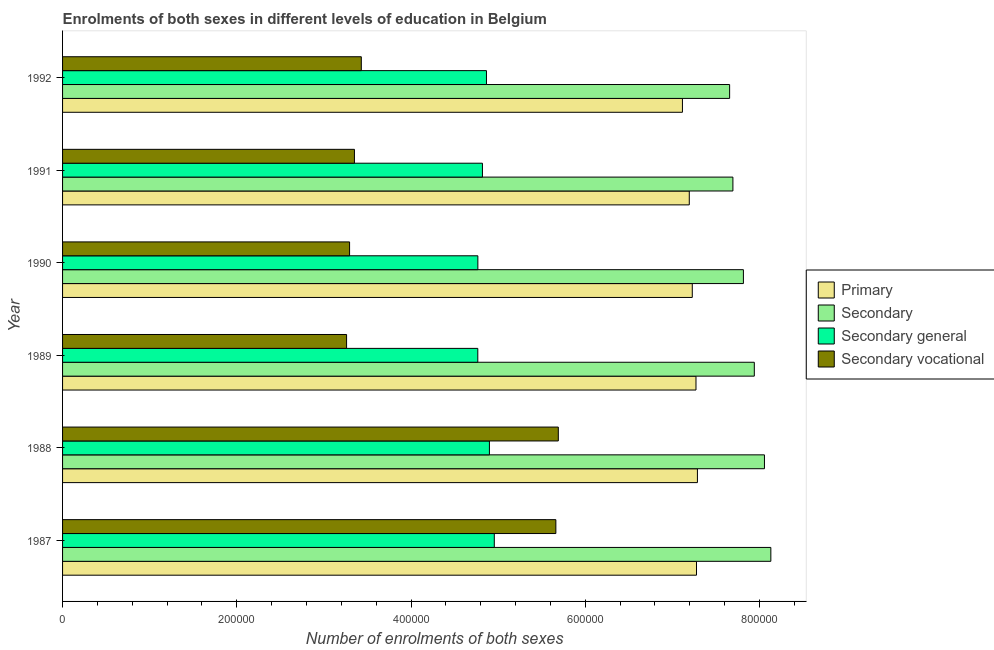How many different coloured bars are there?
Keep it short and to the point. 4. Are the number of bars per tick equal to the number of legend labels?
Make the answer very short. Yes. Are the number of bars on each tick of the Y-axis equal?
Give a very brief answer. Yes. How many bars are there on the 6th tick from the bottom?
Provide a succinct answer. 4. In how many cases, is the number of bars for a given year not equal to the number of legend labels?
Provide a short and direct response. 0. What is the number of enrolments in secondary general education in 1988?
Provide a short and direct response. 4.90e+05. Across all years, what is the maximum number of enrolments in secondary general education?
Offer a very short reply. 4.96e+05. Across all years, what is the minimum number of enrolments in secondary general education?
Provide a succinct answer. 4.77e+05. In which year was the number of enrolments in secondary general education minimum?
Provide a succinct answer. 1989. What is the total number of enrolments in secondary general education in the graph?
Provide a succinct answer. 2.91e+06. What is the difference between the number of enrolments in secondary vocational education in 1990 and that in 1991?
Keep it short and to the point. -5572. What is the difference between the number of enrolments in secondary education in 1988 and the number of enrolments in secondary general education in 1992?
Your answer should be compact. 3.19e+05. What is the average number of enrolments in secondary vocational education per year?
Your answer should be very brief. 4.11e+05. In the year 1991, what is the difference between the number of enrolments in secondary vocational education and number of enrolments in secondary general education?
Your answer should be compact. -1.47e+05. In how many years, is the number of enrolments in secondary vocational education greater than 680000 ?
Your answer should be compact. 0. What is the difference between the highest and the second highest number of enrolments in primary education?
Offer a terse response. 1071. What is the difference between the highest and the lowest number of enrolments in secondary education?
Keep it short and to the point. 4.73e+04. Is the sum of the number of enrolments in secondary vocational education in 1990 and 1992 greater than the maximum number of enrolments in secondary general education across all years?
Your answer should be compact. Yes. Is it the case that in every year, the sum of the number of enrolments in secondary education and number of enrolments in primary education is greater than the sum of number of enrolments in secondary vocational education and number of enrolments in secondary general education?
Your answer should be very brief. No. What does the 2nd bar from the top in 1987 represents?
Your answer should be compact. Secondary general. What does the 4th bar from the bottom in 1989 represents?
Provide a succinct answer. Secondary vocational. Is it the case that in every year, the sum of the number of enrolments in primary education and number of enrolments in secondary education is greater than the number of enrolments in secondary general education?
Offer a terse response. Yes. How many bars are there?
Keep it short and to the point. 24. How many years are there in the graph?
Ensure brevity in your answer.  6. What is the difference between two consecutive major ticks on the X-axis?
Offer a very short reply. 2.00e+05. Does the graph contain any zero values?
Your answer should be very brief. No. Does the graph contain grids?
Make the answer very short. No. Where does the legend appear in the graph?
Your answer should be compact. Center right. How are the legend labels stacked?
Ensure brevity in your answer.  Vertical. What is the title of the graph?
Your response must be concise. Enrolments of both sexes in different levels of education in Belgium. What is the label or title of the X-axis?
Provide a short and direct response. Number of enrolments of both sexes. What is the Number of enrolments of both sexes of Primary in 1987?
Keep it short and to the point. 7.28e+05. What is the Number of enrolments of both sexes in Secondary in 1987?
Provide a short and direct response. 8.13e+05. What is the Number of enrolments of both sexes in Secondary general in 1987?
Make the answer very short. 4.96e+05. What is the Number of enrolments of both sexes in Secondary vocational in 1987?
Offer a terse response. 5.66e+05. What is the Number of enrolments of both sexes in Primary in 1988?
Provide a short and direct response. 7.29e+05. What is the Number of enrolments of both sexes in Secondary in 1988?
Your answer should be compact. 8.06e+05. What is the Number of enrolments of both sexes in Secondary general in 1988?
Keep it short and to the point. 4.90e+05. What is the Number of enrolments of both sexes of Secondary vocational in 1988?
Provide a short and direct response. 5.69e+05. What is the Number of enrolments of both sexes of Primary in 1989?
Your answer should be very brief. 7.27e+05. What is the Number of enrolments of both sexes in Secondary in 1989?
Your answer should be very brief. 7.94e+05. What is the Number of enrolments of both sexes in Secondary general in 1989?
Your answer should be compact. 4.77e+05. What is the Number of enrolments of both sexes in Secondary vocational in 1989?
Provide a short and direct response. 3.26e+05. What is the Number of enrolments of both sexes in Primary in 1990?
Your response must be concise. 7.23e+05. What is the Number of enrolments of both sexes in Secondary in 1990?
Provide a succinct answer. 7.81e+05. What is the Number of enrolments of both sexes of Secondary general in 1990?
Your answer should be compact. 4.77e+05. What is the Number of enrolments of both sexes in Secondary vocational in 1990?
Provide a short and direct response. 3.29e+05. What is the Number of enrolments of both sexes of Primary in 1991?
Provide a succinct answer. 7.19e+05. What is the Number of enrolments of both sexes of Secondary in 1991?
Your response must be concise. 7.69e+05. What is the Number of enrolments of both sexes of Secondary general in 1991?
Keep it short and to the point. 4.82e+05. What is the Number of enrolments of both sexes of Secondary vocational in 1991?
Provide a succinct answer. 3.35e+05. What is the Number of enrolments of both sexes of Primary in 1992?
Your answer should be compact. 7.12e+05. What is the Number of enrolments of both sexes in Secondary in 1992?
Your answer should be very brief. 7.66e+05. What is the Number of enrolments of both sexes in Secondary general in 1992?
Give a very brief answer. 4.87e+05. What is the Number of enrolments of both sexes in Secondary vocational in 1992?
Offer a very short reply. 3.43e+05. Across all years, what is the maximum Number of enrolments of both sexes in Primary?
Provide a short and direct response. 7.29e+05. Across all years, what is the maximum Number of enrolments of both sexes in Secondary?
Your answer should be compact. 8.13e+05. Across all years, what is the maximum Number of enrolments of both sexes of Secondary general?
Ensure brevity in your answer.  4.96e+05. Across all years, what is the maximum Number of enrolments of both sexes of Secondary vocational?
Offer a terse response. 5.69e+05. Across all years, what is the minimum Number of enrolments of both sexes of Primary?
Your answer should be very brief. 7.12e+05. Across all years, what is the minimum Number of enrolments of both sexes of Secondary?
Your answer should be very brief. 7.66e+05. Across all years, what is the minimum Number of enrolments of both sexes of Secondary general?
Make the answer very short. 4.77e+05. Across all years, what is the minimum Number of enrolments of both sexes in Secondary vocational?
Your answer should be very brief. 3.26e+05. What is the total Number of enrolments of both sexes of Primary in the graph?
Your answer should be compact. 4.34e+06. What is the total Number of enrolments of both sexes of Secondary in the graph?
Ensure brevity in your answer.  4.73e+06. What is the total Number of enrolments of both sexes in Secondary general in the graph?
Ensure brevity in your answer.  2.91e+06. What is the total Number of enrolments of both sexes in Secondary vocational in the graph?
Provide a short and direct response. 2.47e+06. What is the difference between the Number of enrolments of both sexes in Primary in 1987 and that in 1988?
Your answer should be compact. -1071. What is the difference between the Number of enrolments of both sexes in Secondary in 1987 and that in 1988?
Your answer should be compact. 7344. What is the difference between the Number of enrolments of both sexes in Secondary general in 1987 and that in 1988?
Give a very brief answer. 5603. What is the difference between the Number of enrolments of both sexes in Secondary vocational in 1987 and that in 1988?
Your answer should be compact. -2811. What is the difference between the Number of enrolments of both sexes in Primary in 1987 and that in 1989?
Ensure brevity in your answer.  587. What is the difference between the Number of enrolments of both sexes in Secondary in 1987 and that in 1989?
Your response must be concise. 1.90e+04. What is the difference between the Number of enrolments of both sexes of Secondary general in 1987 and that in 1989?
Offer a terse response. 1.89e+04. What is the difference between the Number of enrolments of both sexes of Secondary vocational in 1987 and that in 1989?
Give a very brief answer. 2.40e+05. What is the difference between the Number of enrolments of both sexes in Primary in 1987 and that in 1990?
Keep it short and to the point. 4836. What is the difference between the Number of enrolments of both sexes of Secondary in 1987 and that in 1990?
Provide a succinct answer. 3.15e+04. What is the difference between the Number of enrolments of both sexes of Secondary general in 1987 and that in 1990?
Your answer should be very brief. 1.89e+04. What is the difference between the Number of enrolments of both sexes in Secondary vocational in 1987 and that in 1990?
Provide a succinct answer. 2.37e+05. What is the difference between the Number of enrolments of both sexes in Primary in 1987 and that in 1991?
Make the answer very short. 8275. What is the difference between the Number of enrolments of both sexes of Secondary in 1987 and that in 1991?
Offer a terse response. 4.36e+04. What is the difference between the Number of enrolments of both sexes in Secondary general in 1987 and that in 1991?
Offer a very short reply. 1.36e+04. What is the difference between the Number of enrolments of both sexes of Secondary vocational in 1987 and that in 1991?
Your answer should be compact. 2.31e+05. What is the difference between the Number of enrolments of both sexes in Primary in 1987 and that in 1992?
Your answer should be compact. 1.61e+04. What is the difference between the Number of enrolments of both sexes of Secondary in 1987 and that in 1992?
Provide a succinct answer. 4.73e+04. What is the difference between the Number of enrolments of both sexes of Secondary general in 1987 and that in 1992?
Make the answer very short. 8979. What is the difference between the Number of enrolments of both sexes in Secondary vocational in 1987 and that in 1992?
Provide a short and direct response. 2.23e+05. What is the difference between the Number of enrolments of both sexes in Primary in 1988 and that in 1989?
Your answer should be compact. 1658. What is the difference between the Number of enrolments of both sexes in Secondary in 1988 and that in 1989?
Give a very brief answer. 1.16e+04. What is the difference between the Number of enrolments of both sexes in Secondary general in 1988 and that in 1989?
Provide a succinct answer. 1.33e+04. What is the difference between the Number of enrolments of both sexes of Secondary vocational in 1988 and that in 1989?
Offer a very short reply. 2.43e+05. What is the difference between the Number of enrolments of both sexes of Primary in 1988 and that in 1990?
Give a very brief answer. 5907. What is the difference between the Number of enrolments of both sexes in Secondary in 1988 and that in 1990?
Offer a terse response. 2.42e+04. What is the difference between the Number of enrolments of both sexes of Secondary general in 1988 and that in 1990?
Give a very brief answer. 1.33e+04. What is the difference between the Number of enrolments of both sexes in Secondary vocational in 1988 and that in 1990?
Your answer should be very brief. 2.40e+05. What is the difference between the Number of enrolments of both sexes in Primary in 1988 and that in 1991?
Keep it short and to the point. 9346. What is the difference between the Number of enrolments of both sexes in Secondary in 1988 and that in 1991?
Provide a succinct answer. 3.62e+04. What is the difference between the Number of enrolments of both sexes in Secondary general in 1988 and that in 1991?
Offer a very short reply. 8005. What is the difference between the Number of enrolments of both sexes of Secondary vocational in 1988 and that in 1991?
Provide a succinct answer. 2.34e+05. What is the difference between the Number of enrolments of both sexes of Primary in 1988 and that in 1992?
Make the answer very short. 1.72e+04. What is the difference between the Number of enrolments of both sexes of Secondary in 1988 and that in 1992?
Your answer should be very brief. 4.00e+04. What is the difference between the Number of enrolments of both sexes in Secondary general in 1988 and that in 1992?
Your answer should be very brief. 3376. What is the difference between the Number of enrolments of both sexes in Secondary vocational in 1988 and that in 1992?
Provide a succinct answer. 2.26e+05. What is the difference between the Number of enrolments of both sexes of Primary in 1989 and that in 1990?
Your answer should be very brief. 4249. What is the difference between the Number of enrolments of both sexes of Secondary in 1989 and that in 1990?
Keep it short and to the point. 1.25e+04. What is the difference between the Number of enrolments of both sexes in Secondary general in 1989 and that in 1990?
Offer a terse response. -78. What is the difference between the Number of enrolments of both sexes in Secondary vocational in 1989 and that in 1990?
Offer a terse response. -3443. What is the difference between the Number of enrolments of both sexes of Primary in 1989 and that in 1991?
Offer a very short reply. 7688. What is the difference between the Number of enrolments of both sexes of Secondary in 1989 and that in 1991?
Your answer should be compact. 2.46e+04. What is the difference between the Number of enrolments of both sexes of Secondary general in 1989 and that in 1991?
Provide a short and direct response. -5336. What is the difference between the Number of enrolments of both sexes of Secondary vocational in 1989 and that in 1991?
Provide a short and direct response. -9015. What is the difference between the Number of enrolments of both sexes in Primary in 1989 and that in 1992?
Provide a short and direct response. 1.55e+04. What is the difference between the Number of enrolments of both sexes in Secondary in 1989 and that in 1992?
Offer a very short reply. 2.84e+04. What is the difference between the Number of enrolments of both sexes in Secondary general in 1989 and that in 1992?
Give a very brief answer. -9965. What is the difference between the Number of enrolments of both sexes of Secondary vocational in 1989 and that in 1992?
Your answer should be very brief. -1.69e+04. What is the difference between the Number of enrolments of both sexes of Primary in 1990 and that in 1991?
Provide a short and direct response. 3439. What is the difference between the Number of enrolments of both sexes in Secondary in 1990 and that in 1991?
Keep it short and to the point. 1.20e+04. What is the difference between the Number of enrolments of both sexes of Secondary general in 1990 and that in 1991?
Offer a terse response. -5258. What is the difference between the Number of enrolments of both sexes of Secondary vocational in 1990 and that in 1991?
Offer a terse response. -5572. What is the difference between the Number of enrolments of both sexes in Primary in 1990 and that in 1992?
Offer a terse response. 1.13e+04. What is the difference between the Number of enrolments of both sexes of Secondary in 1990 and that in 1992?
Keep it short and to the point. 1.58e+04. What is the difference between the Number of enrolments of both sexes of Secondary general in 1990 and that in 1992?
Your answer should be compact. -9887. What is the difference between the Number of enrolments of both sexes of Secondary vocational in 1990 and that in 1992?
Give a very brief answer. -1.35e+04. What is the difference between the Number of enrolments of both sexes of Primary in 1991 and that in 1992?
Keep it short and to the point. 7851. What is the difference between the Number of enrolments of both sexes of Secondary in 1991 and that in 1992?
Provide a succinct answer. 3766. What is the difference between the Number of enrolments of both sexes of Secondary general in 1991 and that in 1992?
Make the answer very short. -4629. What is the difference between the Number of enrolments of both sexes of Secondary vocational in 1991 and that in 1992?
Give a very brief answer. -7892. What is the difference between the Number of enrolments of both sexes of Primary in 1987 and the Number of enrolments of both sexes of Secondary in 1988?
Your response must be concise. -7.80e+04. What is the difference between the Number of enrolments of both sexes in Primary in 1987 and the Number of enrolments of both sexes in Secondary general in 1988?
Ensure brevity in your answer.  2.38e+05. What is the difference between the Number of enrolments of both sexes of Primary in 1987 and the Number of enrolments of both sexes of Secondary vocational in 1988?
Provide a short and direct response. 1.59e+05. What is the difference between the Number of enrolments of both sexes in Secondary in 1987 and the Number of enrolments of both sexes in Secondary general in 1988?
Keep it short and to the point. 3.23e+05. What is the difference between the Number of enrolments of both sexes of Secondary in 1987 and the Number of enrolments of both sexes of Secondary vocational in 1988?
Provide a succinct answer. 2.44e+05. What is the difference between the Number of enrolments of both sexes in Secondary general in 1987 and the Number of enrolments of both sexes in Secondary vocational in 1988?
Give a very brief answer. -7.35e+04. What is the difference between the Number of enrolments of both sexes of Primary in 1987 and the Number of enrolments of both sexes of Secondary in 1989?
Give a very brief answer. -6.64e+04. What is the difference between the Number of enrolments of both sexes of Primary in 1987 and the Number of enrolments of both sexes of Secondary general in 1989?
Offer a terse response. 2.51e+05. What is the difference between the Number of enrolments of both sexes of Primary in 1987 and the Number of enrolments of both sexes of Secondary vocational in 1989?
Offer a terse response. 4.02e+05. What is the difference between the Number of enrolments of both sexes in Secondary in 1987 and the Number of enrolments of both sexes in Secondary general in 1989?
Provide a succinct answer. 3.36e+05. What is the difference between the Number of enrolments of both sexes of Secondary in 1987 and the Number of enrolments of both sexes of Secondary vocational in 1989?
Make the answer very short. 4.87e+05. What is the difference between the Number of enrolments of both sexes in Secondary general in 1987 and the Number of enrolments of both sexes in Secondary vocational in 1989?
Your answer should be compact. 1.70e+05. What is the difference between the Number of enrolments of both sexes in Primary in 1987 and the Number of enrolments of both sexes in Secondary in 1990?
Offer a terse response. -5.38e+04. What is the difference between the Number of enrolments of both sexes in Primary in 1987 and the Number of enrolments of both sexes in Secondary general in 1990?
Offer a very short reply. 2.51e+05. What is the difference between the Number of enrolments of both sexes in Primary in 1987 and the Number of enrolments of both sexes in Secondary vocational in 1990?
Your answer should be very brief. 3.98e+05. What is the difference between the Number of enrolments of both sexes of Secondary in 1987 and the Number of enrolments of both sexes of Secondary general in 1990?
Your answer should be compact. 3.36e+05. What is the difference between the Number of enrolments of both sexes in Secondary in 1987 and the Number of enrolments of both sexes in Secondary vocational in 1990?
Your response must be concise. 4.84e+05. What is the difference between the Number of enrolments of both sexes in Secondary general in 1987 and the Number of enrolments of both sexes in Secondary vocational in 1990?
Your answer should be compact. 1.66e+05. What is the difference between the Number of enrolments of both sexes of Primary in 1987 and the Number of enrolments of both sexes of Secondary in 1991?
Keep it short and to the point. -4.18e+04. What is the difference between the Number of enrolments of both sexes in Primary in 1987 and the Number of enrolments of both sexes in Secondary general in 1991?
Your answer should be very brief. 2.46e+05. What is the difference between the Number of enrolments of both sexes of Primary in 1987 and the Number of enrolments of both sexes of Secondary vocational in 1991?
Keep it short and to the point. 3.93e+05. What is the difference between the Number of enrolments of both sexes of Secondary in 1987 and the Number of enrolments of both sexes of Secondary general in 1991?
Make the answer very short. 3.31e+05. What is the difference between the Number of enrolments of both sexes of Secondary in 1987 and the Number of enrolments of both sexes of Secondary vocational in 1991?
Offer a very short reply. 4.78e+05. What is the difference between the Number of enrolments of both sexes of Secondary general in 1987 and the Number of enrolments of both sexes of Secondary vocational in 1991?
Make the answer very short. 1.61e+05. What is the difference between the Number of enrolments of both sexes of Primary in 1987 and the Number of enrolments of both sexes of Secondary in 1992?
Your answer should be compact. -3.80e+04. What is the difference between the Number of enrolments of both sexes of Primary in 1987 and the Number of enrolments of both sexes of Secondary general in 1992?
Your answer should be compact. 2.41e+05. What is the difference between the Number of enrolments of both sexes in Primary in 1987 and the Number of enrolments of both sexes in Secondary vocational in 1992?
Offer a terse response. 3.85e+05. What is the difference between the Number of enrolments of both sexes of Secondary in 1987 and the Number of enrolments of both sexes of Secondary general in 1992?
Provide a short and direct response. 3.26e+05. What is the difference between the Number of enrolments of both sexes of Secondary in 1987 and the Number of enrolments of both sexes of Secondary vocational in 1992?
Make the answer very short. 4.70e+05. What is the difference between the Number of enrolments of both sexes of Secondary general in 1987 and the Number of enrolments of both sexes of Secondary vocational in 1992?
Make the answer very short. 1.53e+05. What is the difference between the Number of enrolments of both sexes in Primary in 1988 and the Number of enrolments of both sexes in Secondary in 1989?
Provide a succinct answer. -6.53e+04. What is the difference between the Number of enrolments of both sexes of Primary in 1988 and the Number of enrolments of both sexes of Secondary general in 1989?
Your answer should be very brief. 2.52e+05. What is the difference between the Number of enrolments of both sexes in Primary in 1988 and the Number of enrolments of both sexes in Secondary vocational in 1989?
Your answer should be very brief. 4.03e+05. What is the difference between the Number of enrolments of both sexes in Secondary in 1988 and the Number of enrolments of both sexes in Secondary general in 1989?
Offer a terse response. 3.29e+05. What is the difference between the Number of enrolments of both sexes in Secondary in 1988 and the Number of enrolments of both sexes in Secondary vocational in 1989?
Offer a very short reply. 4.80e+05. What is the difference between the Number of enrolments of both sexes in Secondary general in 1988 and the Number of enrolments of both sexes in Secondary vocational in 1989?
Keep it short and to the point. 1.64e+05. What is the difference between the Number of enrolments of both sexes in Primary in 1988 and the Number of enrolments of both sexes in Secondary in 1990?
Provide a succinct answer. -5.28e+04. What is the difference between the Number of enrolments of both sexes of Primary in 1988 and the Number of enrolments of both sexes of Secondary general in 1990?
Make the answer very short. 2.52e+05. What is the difference between the Number of enrolments of both sexes of Primary in 1988 and the Number of enrolments of both sexes of Secondary vocational in 1990?
Provide a succinct answer. 3.99e+05. What is the difference between the Number of enrolments of both sexes in Secondary in 1988 and the Number of enrolments of both sexes in Secondary general in 1990?
Give a very brief answer. 3.29e+05. What is the difference between the Number of enrolments of both sexes in Secondary in 1988 and the Number of enrolments of both sexes in Secondary vocational in 1990?
Your answer should be very brief. 4.76e+05. What is the difference between the Number of enrolments of both sexes of Secondary general in 1988 and the Number of enrolments of both sexes of Secondary vocational in 1990?
Give a very brief answer. 1.61e+05. What is the difference between the Number of enrolments of both sexes of Primary in 1988 and the Number of enrolments of both sexes of Secondary in 1991?
Keep it short and to the point. -4.07e+04. What is the difference between the Number of enrolments of both sexes of Primary in 1988 and the Number of enrolments of both sexes of Secondary general in 1991?
Your answer should be compact. 2.47e+05. What is the difference between the Number of enrolments of both sexes in Primary in 1988 and the Number of enrolments of both sexes in Secondary vocational in 1991?
Keep it short and to the point. 3.94e+05. What is the difference between the Number of enrolments of both sexes in Secondary in 1988 and the Number of enrolments of both sexes in Secondary general in 1991?
Keep it short and to the point. 3.24e+05. What is the difference between the Number of enrolments of both sexes in Secondary in 1988 and the Number of enrolments of both sexes in Secondary vocational in 1991?
Make the answer very short. 4.71e+05. What is the difference between the Number of enrolments of both sexes in Secondary general in 1988 and the Number of enrolments of both sexes in Secondary vocational in 1991?
Keep it short and to the point. 1.55e+05. What is the difference between the Number of enrolments of both sexes of Primary in 1988 and the Number of enrolments of both sexes of Secondary in 1992?
Provide a short and direct response. -3.70e+04. What is the difference between the Number of enrolments of both sexes of Primary in 1988 and the Number of enrolments of both sexes of Secondary general in 1992?
Give a very brief answer. 2.42e+05. What is the difference between the Number of enrolments of both sexes of Primary in 1988 and the Number of enrolments of both sexes of Secondary vocational in 1992?
Keep it short and to the point. 3.86e+05. What is the difference between the Number of enrolments of both sexes in Secondary in 1988 and the Number of enrolments of both sexes in Secondary general in 1992?
Ensure brevity in your answer.  3.19e+05. What is the difference between the Number of enrolments of both sexes in Secondary in 1988 and the Number of enrolments of both sexes in Secondary vocational in 1992?
Keep it short and to the point. 4.63e+05. What is the difference between the Number of enrolments of both sexes of Secondary general in 1988 and the Number of enrolments of both sexes of Secondary vocational in 1992?
Your response must be concise. 1.47e+05. What is the difference between the Number of enrolments of both sexes in Primary in 1989 and the Number of enrolments of both sexes in Secondary in 1990?
Offer a terse response. -5.44e+04. What is the difference between the Number of enrolments of both sexes in Primary in 1989 and the Number of enrolments of both sexes in Secondary general in 1990?
Make the answer very short. 2.50e+05. What is the difference between the Number of enrolments of both sexes of Primary in 1989 and the Number of enrolments of both sexes of Secondary vocational in 1990?
Give a very brief answer. 3.98e+05. What is the difference between the Number of enrolments of both sexes of Secondary in 1989 and the Number of enrolments of both sexes of Secondary general in 1990?
Give a very brief answer. 3.17e+05. What is the difference between the Number of enrolments of both sexes in Secondary in 1989 and the Number of enrolments of both sexes in Secondary vocational in 1990?
Your answer should be very brief. 4.65e+05. What is the difference between the Number of enrolments of both sexes in Secondary general in 1989 and the Number of enrolments of both sexes in Secondary vocational in 1990?
Give a very brief answer. 1.47e+05. What is the difference between the Number of enrolments of both sexes of Primary in 1989 and the Number of enrolments of both sexes of Secondary in 1991?
Provide a succinct answer. -4.24e+04. What is the difference between the Number of enrolments of both sexes of Primary in 1989 and the Number of enrolments of both sexes of Secondary general in 1991?
Keep it short and to the point. 2.45e+05. What is the difference between the Number of enrolments of both sexes in Primary in 1989 and the Number of enrolments of both sexes in Secondary vocational in 1991?
Make the answer very short. 3.92e+05. What is the difference between the Number of enrolments of both sexes of Secondary in 1989 and the Number of enrolments of both sexes of Secondary general in 1991?
Your response must be concise. 3.12e+05. What is the difference between the Number of enrolments of both sexes of Secondary in 1989 and the Number of enrolments of both sexes of Secondary vocational in 1991?
Offer a very short reply. 4.59e+05. What is the difference between the Number of enrolments of both sexes of Secondary general in 1989 and the Number of enrolments of both sexes of Secondary vocational in 1991?
Make the answer very short. 1.42e+05. What is the difference between the Number of enrolments of both sexes in Primary in 1989 and the Number of enrolments of both sexes in Secondary in 1992?
Your answer should be very brief. -3.86e+04. What is the difference between the Number of enrolments of both sexes in Primary in 1989 and the Number of enrolments of both sexes in Secondary general in 1992?
Provide a succinct answer. 2.40e+05. What is the difference between the Number of enrolments of both sexes of Primary in 1989 and the Number of enrolments of both sexes of Secondary vocational in 1992?
Give a very brief answer. 3.84e+05. What is the difference between the Number of enrolments of both sexes in Secondary in 1989 and the Number of enrolments of both sexes in Secondary general in 1992?
Give a very brief answer. 3.07e+05. What is the difference between the Number of enrolments of both sexes in Secondary in 1989 and the Number of enrolments of both sexes in Secondary vocational in 1992?
Your answer should be very brief. 4.51e+05. What is the difference between the Number of enrolments of both sexes of Secondary general in 1989 and the Number of enrolments of both sexes of Secondary vocational in 1992?
Offer a terse response. 1.34e+05. What is the difference between the Number of enrolments of both sexes of Primary in 1990 and the Number of enrolments of both sexes of Secondary in 1991?
Offer a terse response. -4.66e+04. What is the difference between the Number of enrolments of both sexes of Primary in 1990 and the Number of enrolments of both sexes of Secondary general in 1991?
Keep it short and to the point. 2.41e+05. What is the difference between the Number of enrolments of both sexes of Primary in 1990 and the Number of enrolments of both sexes of Secondary vocational in 1991?
Your response must be concise. 3.88e+05. What is the difference between the Number of enrolments of both sexes in Secondary in 1990 and the Number of enrolments of both sexes in Secondary general in 1991?
Provide a short and direct response. 3.00e+05. What is the difference between the Number of enrolments of both sexes in Secondary in 1990 and the Number of enrolments of both sexes in Secondary vocational in 1991?
Your answer should be very brief. 4.46e+05. What is the difference between the Number of enrolments of both sexes of Secondary general in 1990 and the Number of enrolments of both sexes of Secondary vocational in 1991?
Keep it short and to the point. 1.42e+05. What is the difference between the Number of enrolments of both sexes in Primary in 1990 and the Number of enrolments of both sexes in Secondary in 1992?
Keep it short and to the point. -4.29e+04. What is the difference between the Number of enrolments of both sexes of Primary in 1990 and the Number of enrolments of both sexes of Secondary general in 1992?
Your answer should be very brief. 2.36e+05. What is the difference between the Number of enrolments of both sexes in Primary in 1990 and the Number of enrolments of both sexes in Secondary vocational in 1992?
Offer a terse response. 3.80e+05. What is the difference between the Number of enrolments of both sexes in Secondary in 1990 and the Number of enrolments of both sexes in Secondary general in 1992?
Make the answer very short. 2.95e+05. What is the difference between the Number of enrolments of both sexes in Secondary in 1990 and the Number of enrolments of both sexes in Secondary vocational in 1992?
Give a very brief answer. 4.39e+05. What is the difference between the Number of enrolments of both sexes of Secondary general in 1990 and the Number of enrolments of both sexes of Secondary vocational in 1992?
Offer a terse response. 1.34e+05. What is the difference between the Number of enrolments of both sexes in Primary in 1991 and the Number of enrolments of both sexes in Secondary in 1992?
Your response must be concise. -4.63e+04. What is the difference between the Number of enrolments of both sexes of Primary in 1991 and the Number of enrolments of both sexes of Secondary general in 1992?
Offer a very short reply. 2.33e+05. What is the difference between the Number of enrolments of both sexes of Primary in 1991 and the Number of enrolments of both sexes of Secondary vocational in 1992?
Provide a succinct answer. 3.76e+05. What is the difference between the Number of enrolments of both sexes in Secondary in 1991 and the Number of enrolments of both sexes in Secondary general in 1992?
Offer a very short reply. 2.83e+05. What is the difference between the Number of enrolments of both sexes in Secondary in 1991 and the Number of enrolments of both sexes in Secondary vocational in 1992?
Offer a terse response. 4.27e+05. What is the difference between the Number of enrolments of both sexes of Secondary general in 1991 and the Number of enrolments of both sexes of Secondary vocational in 1992?
Offer a terse response. 1.39e+05. What is the average Number of enrolments of both sexes of Primary per year?
Offer a terse response. 7.23e+05. What is the average Number of enrolments of both sexes in Secondary per year?
Ensure brevity in your answer.  7.88e+05. What is the average Number of enrolments of both sexes in Secondary general per year?
Ensure brevity in your answer.  4.85e+05. What is the average Number of enrolments of both sexes of Secondary vocational per year?
Your answer should be compact. 4.11e+05. In the year 1987, what is the difference between the Number of enrolments of both sexes in Primary and Number of enrolments of both sexes in Secondary?
Your answer should be very brief. -8.53e+04. In the year 1987, what is the difference between the Number of enrolments of both sexes of Primary and Number of enrolments of both sexes of Secondary general?
Your answer should be very brief. 2.32e+05. In the year 1987, what is the difference between the Number of enrolments of both sexes in Primary and Number of enrolments of both sexes in Secondary vocational?
Provide a short and direct response. 1.61e+05. In the year 1987, what is the difference between the Number of enrolments of both sexes in Secondary and Number of enrolments of both sexes in Secondary general?
Your answer should be very brief. 3.17e+05. In the year 1987, what is the difference between the Number of enrolments of both sexes in Secondary and Number of enrolments of both sexes in Secondary vocational?
Make the answer very short. 2.47e+05. In the year 1987, what is the difference between the Number of enrolments of both sexes in Secondary general and Number of enrolments of both sexes in Secondary vocational?
Provide a short and direct response. -7.07e+04. In the year 1988, what is the difference between the Number of enrolments of both sexes in Primary and Number of enrolments of both sexes in Secondary?
Ensure brevity in your answer.  -7.69e+04. In the year 1988, what is the difference between the Number of enrolments of both sexes of Primary and Number of enrolments of both sexes of Secondary general?
Offer a terse response. 2.39e+05. In the year 1988, what is the difference between the Number of enrolments of both sexes of Primary and Number of enrolments of both sexes of Secondary vocational?
Make the answer very short. 1.60e+05. In the year 1988, what is the difference between the Number of enrolments of both sexes of Secondary and Number of enrolments of both sexes of Secondary general?
Your response must be concise. 3.16e+05. In the year 1988, what is the difference between the Number of enrolments of both sexes in Secondary and Number of enrolments of both sexes in Secondary vocational?
Offer a terse response. 2.37e+05. In the year 1988, what is the difference between the Number of enrolments of both sexes in Secondary general and Number of enrolments of both sexes in Secondary vocational?
Offer a terse response. -7.91e+04. In the year 1989, what is the difference between the Number of enrolments of both sexes in Primary and Number of enrolments of both sexes in Secondary?
Keep it short and to the point. -6.70e+04. In the year 1989, what is the difference between the Number of enrolments of both sexes of Primary and Number of enrolments of both sexes of Secondary general?
Make the answer very short. 2.50e+05. In the year 1989, what is the difference between the Number of enrolments of both sexes of Primary and Number of enrolments of both sexes of Secondary vocational?
Provide a short and direct response. 4.01e+05. In the year 1989, what is the difference between the Number of enrolments of both sexes in Secondary and Number of enrolments of both sexes in Secondary general?
Offer a terse response. 3.17e+05. In the year 1989, what is the difference between the Number of enrolments of both sexes in Secondary and Number of enrolments of both sexes in Secondary vocational?
Make the answer very short. 4.68e+05. In the year 1989, what is the difference between the Number of enrolments of both sexes of Secondary general and Number of enrolments of both sexes of Secondary vocational?
Offer a very short reply. 1.51e+05. In the year 1990, what is the difference between the Number of enrolments of both sexes in Primary and Number of enrolments of both sexes in Secondary?
Ensure brevity in your answer.  -5.87e+04. In the year 1990, what is the difference between the Number of enrolments of both sexes in Primary and Number of enrolments of both sexes in Secondary general?
Make the answer very short. 2.46e+05. In the year 1990, what is the difference between the Number of enrolments of both sexes of Primary and Number of enrolments of both sexes of Secondary vocational?
Your answer should be compact. 3.93e+05. In the year 1990, what is the difference between the Number of enrolments of both sexes of Secondary and Number of enrolments of both sexes of Secondary general?
Keep it short and to the point. 3.05e+05. In the year 1990, what is the difference between the Number of enrolments of both sexes in Secondary and Number of enrolments of both sexes in Secondary vocational?
Your answer should be very brief. 4.52e+05. In the year 1990, what is the difference between the Number of enrolments of both sexes in Secondary general and Number of enrolments of both sexes in Secondary vocational?
Make the answer very short. 1.47e+05. In the year 1991, what is the difference between the Number of enrolments of both sexes of Primary and Number of enrolments of both sexes of Secondary?
Give a very brief answer. -5.01e+04. In the year 1991, what is the difference between the Number of enrolments of both sexes of Primary and Number of enrolments of both sexes of Secondary general?
Your response must be concise. 2.37e+05. In the year 1991, what is the difference between the Number of enrolments of both sexes of Primary and Number of enrolments of both sexes of Secondary vocational?
Offer a terse response. 3.84e+05. In the year 1991, what is the difference between the Number of enrolments of both sexes of Secondary and Number of enrolments of both sexes of Secondary general?
Provide a short and direct response. 2.87e+05. In the year 1991, what is the difference between the Number of enrolments of both sexes in Secondary and Number of enrolments of both sexes in Secondary vocational?
Your response must be concise. 4.34e+05. In the year 1991, what is the difference between the Number of enrolments of both sexes of Secondary general and Number of enrolments of both sexes of Secondary vocational?
Make the answer very short. 1.47e+05. In the year 1992, what is the difference between the Number of enrolments of both sexes of Primary and Number of enrolments of both sexes of Secondary?
Your answer should be compact. -5.42e+04. In the year 1992, what is the difference between the Number of enrolments of both sexes of Primary and Number of enrolments of both sexes of Secondary general?
Provide a short and direct response. 2.25e+05. In the year 1992, what is the difference between the Number of enrolments of both sexes in Primary and Number of enrolments of both sexes in Secondary vocational?
Make the answer very short. 3.69e+05. In the year 1992, what is the difference between the Number of enrolments of both sexes of Secondary and Number of enrolments of both sexes of Secondary general?
Offer a very short reply. 2.79e+05. In the year 1992, what is the difference between the Number of enrolments of both sexes in Secondary and Number of enrolments of both sexes in Secondary vocational?
Keep it short and to the point. 4.23e+05. In the year 1992, what is the difference between the Number of enrolments of both sexes of Secondary general and Number of enrolments of both sexes of Secondary vocational?
Your answer should be very brief. 1.44e+05. What is the ratio of the Number of enrolments of both sexes of Secondary in 1987 to that in 1988?
Offer a terse response. 1.01. What is the ratio of the Number of enrolments of both sexes of Secondary general in 1987 to that in 1988?
Provide a succinct answer. 1.01. What is the ratio of the Number of enrolments of both sexes in Secondary in 1987 to that in 1989?
Provide a succinct answer. 1.02. What is the ratio of the Number of enrolments of both sexes in Secondary general in 1987 to that in 1989?
Offer a terse response. 1.04. What is the ratio of the Number of enrolments of both sexes in Secondary vocational in 1987 to that in 1989?
Give a very brief answer. 1.74. What is the ratio of the Number of enrolments of both sexes of Secondary in 1987 to that in 1990?
Provide a succinct answer. 1.04. What is the ratio of the Number of enrolments of both sexes of Secondary general in 1987 to that in 1990?
Provide a succinct answer. 1.04. What is the ratio of the Number of enrolments of both sexes in Secondary vocational in 1987 to that in 1990?
Your response must be concise. 1.72. What is the ratio of the Number of enrolments of both sexes in Primary in 1987 to that in 1991?
Give a very brief answer. 1.01. What is the ratio of the Number of enrolments of both sexes in Secondary in 1987 to that in 1991?
Offer a terse response. 1.06. What is the ratio of the Number of enrolments of both sexes of Secondary general in 1987 to that in 1991?
Offer a terse response. 1.03. What is the ratio of the Number of enrolments of both sexes in Secondary vocational in 1987 to that in 1991?
Your response must be concise. 1.69. What is the ratio of the Number of enrolments of both sexes of Primary in 1987 to that in 1992?
Keep it short and to the point. 1.02. What is the ratio of the Number of enrolments of both sexes in Secondary in 1987 to that in 1992?
Give a very brief answer. 1.06. What is the ratio of the Number of enrolments of both sexes of Secondary general in 1987 to that in 1992?
Keep it short and to the point. 1.02. What is the ratio of the Number of enrolments of both sexes of Secondary vocational in 1987 to that in 1992?
Give a very brief answer. 1.65. What is the ratio of the Number of enrolments of both sexes of Primary in 1988 to that in 1989?
Give a very brief answer. 1. What is the ratio of the Number of enrolments of both sexes of Secondary in 1988 to that in 1989?
Provide a short and direct response. 1.01. What is the ratio of the Number of enrolments of both sexes of Secondary general in 1988 to that in 1989?
Offer a terse response. 1.03. What is the ratio of the Number of enrolments of both sexes of Secondary vocational in 1988 to that in 1989?
Provide a short and direct response. 1.75. What is the ratio of the Number of enrolments of both sexes in Primary in 1988 to that in 1990?
Make the answer very short. 1.01. What is the ratio of the Number of enrolments of both sexes of Secondary in 1988 to that in 1990?
Offer a terse response. 1.03. What is the ratio of the Number of enrolments of both sexes in Secondary general in 1988 to that in 1990?
Your response must be concise. 1.03. What is the ratio of the Number of enrolments of both sexes of Secondary vocational in 1988 to that in 1990?
Provide a succinct answer. 1.73. What is the ratio of the Number of enrolments of both sexes in Secondary in 1988 to that in 1991?
Provide a succinct answer. 1.05. What is the ratio of the Number of enrolments of both sexes in Secondary general in 1988 to that in 1991?
Offer a very short reply. 1.02. What is the ratio of the Number of enrolments of both sexes of Secondary vocational in 1988 to that in 1991?
Make the answer very short. 1.7. What is the ratio of the Number of enrolments of both sexes of Primary in 1988 to that in 1992?
Your answer should be compact. 1.02. What is the ratio of the Number of enrolments of both sexes of Secondary in 1988 to that in 1992?
Your answer should be very brief. 1.05. What is the ratio of the Number of enrolments of both sexes of Secondary vocational in 1988 to that in 1992?
Your answer should be very brief. 1.66. What is the ratio of the Number of enrolments of both sexes of Primary in 1989 to that in 1990?
Your answer should be compact. 1.01. What is the ratio of the Number of enrolments of both sexes of Secondary in 1989 to that in 1990?
Your response must be concise. 1.02. What is the ratio of the Number of enrolments of both sexes of Primary in 1989 to that in 1991?
Keep it short and to the point. 1.01. What is the ratio of the Number of enrolments of both sexes in Secondary in 1989 to that in 1991?
Offer a very short reply. 1.03. What is the ratio of the Number of enrolments of both sexes in Secondary general in 1989 to that in 1991?
Make the answer very short. 0.99. What is the ratio of the Number of enrolments of both sexes of Secondary vocational in 1989 to that in 1991?
Give a very brief answer. 0.97. What is the ratio of the Number of enrolments of both sexes of Primary in 1989 to that in 1992?
Provide a short and direct response. 1.02. What is the ratio of the Number of enrolments of both sexes of Secondary in 1989 to that in 1992?
Give a very brief answer. 1.04. What is the ratio of the Number of enrolments of both sexes in Secondary general in 1989 to that in 1992?
Ensure brevity in your answer.  0.98. What is the ratio of the Number of enrolments of both sexes in Secondary vocational in 1989 to that in 1992?
Your response must be concise. 0.95. What is the ratio of the Number of enrolments of both sexes in Primary in 1990 to that in 1991?
Your response must be concise. 1. What is the ratio of the Number of enrolments of both sexes of Secondary in 1990 to that in 1991?
Make the answer very short. 1.02. What is the ratio of the Number of enrolments of both sexes in Secondary general in 1990 to that in 1991?
Your response must be concise. 0.99. What is the ratio of the Number of enrolments of both sexes in Secondary vocational in 1990 to that in 1991?
Your answer should be compact. 0.98. What is the ratio of the Number of enrolments of both sexes in Primary in 1990 to that in 1992?
Provide a succinct answer. 1.02. What is the ratio of the Number of enrolments of both sexes of Secondary in 1990 to that in 1992?
Make the answer very short. 1.02. What is the ratio of the Number of enrolments of both sexes in Secondary general in 1990 to that in 1992?
Offer a terse response. 0.98. What is the ratio of the Number of enrolments of both sexes in Secondary vocational in 1990 to that in 1992?
Give a very brief answer. 0.96. What is the ratio of the Number of enrolments of both sexes in Secondary in 1991 to that in 1992?
Offer a terse response. 1. What is the ratio of the Number of enrolments of both sexes of Secondary vocational in 1991 to that in 1992?
Provide a short and direct response. 0.98. What is the difference between the highest and the second highest Number of enrolments of both sexes of Primary?
Provide a succinct answer. 1071. What is the difference between the highest and the second highest Number of enrolments of both sexes in Secondary?
Your answer should be very brief. 7344. What is the difference between the highest and the second highest Number of enrolments of both sexes in Secondary general?
Provide a short and direct response. 5603. What is the difference between the highest and the second highest Number of enrolments of both sexes in Secondary vocational?
Your answer should be compact. 2811. What is the difference between the highest and the lowest Number of enrolments of both sexes of Primary?
Offer a very short reply. 1.72e+04. What is the difference between the highest and the lowest Number of enrolments of both sexes in Secondary?
Provide a short and direct response. 4.73e+04. What is the difference between the highest and the lowest Number of enrolments of both sexes in Secondary general?
Your answer should be compact. 1.89e+04. What is the difference between the highest and the lowest Number of enrolments of both sexes in Secondary vocational?
Ensure brevity in your answer.  2.43e+05. 